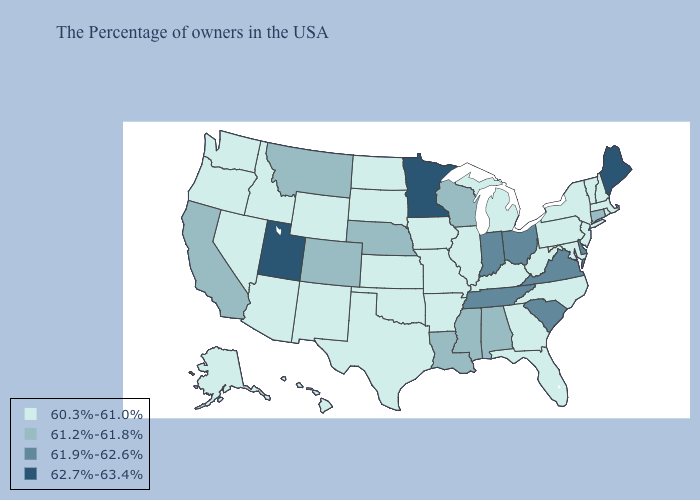Name the states that have a value in the range 61.9%-62.6%?
Be succinct. Delaware, Virginia, South Carolina, Ohio, Indiana, Tennessee. Among the states that border Tennessee , does Arkansas have the lowest value?
Short answer required. Yes. What is the highest value in the West ?
Answer briefly. 62.7%-63.4%. What is the lowest value in the MidWest?
Concise answer only. 60.3%-61.0%. Which states have the highest value in the USA?
Quick response, please. Maine, Minnesota, Utah. What is the highest value in states that border Virginia?
Quick response, please. 61.9%-62.6%. What is the highest value in the MidWest ?
Give a very brief answer. 62.7%-63.4%. Does California have the lowest value in the USA?
Give a very brief answer. No. Which states hav the highest value in the West?
Concise answer only. Utah. Does Indiana have the lowest value in the MidWest?
Concise answer only. No. Does New York have the same value as Mississippi?
Write a very short answer. No. Name the states that have a value in the range 61.2%-61.8%?
Give a very brief answer. Connecticut, Alabama, Wisconsin, Mississippi, Louisiana, Nebraska, Colorado, Montana, California. What is the value of Oregon?
Quick response, please. 60.3%-61.0%. What is the lowest value in the MidWest?
Keep it brief. 60.3%-61.0%. What is the value of Maryland?
Short answer required. 60.3%-61.0%. 